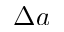<formula> <loc_0><loc_0><loc_500><loc_500>\Delta a</formula> 